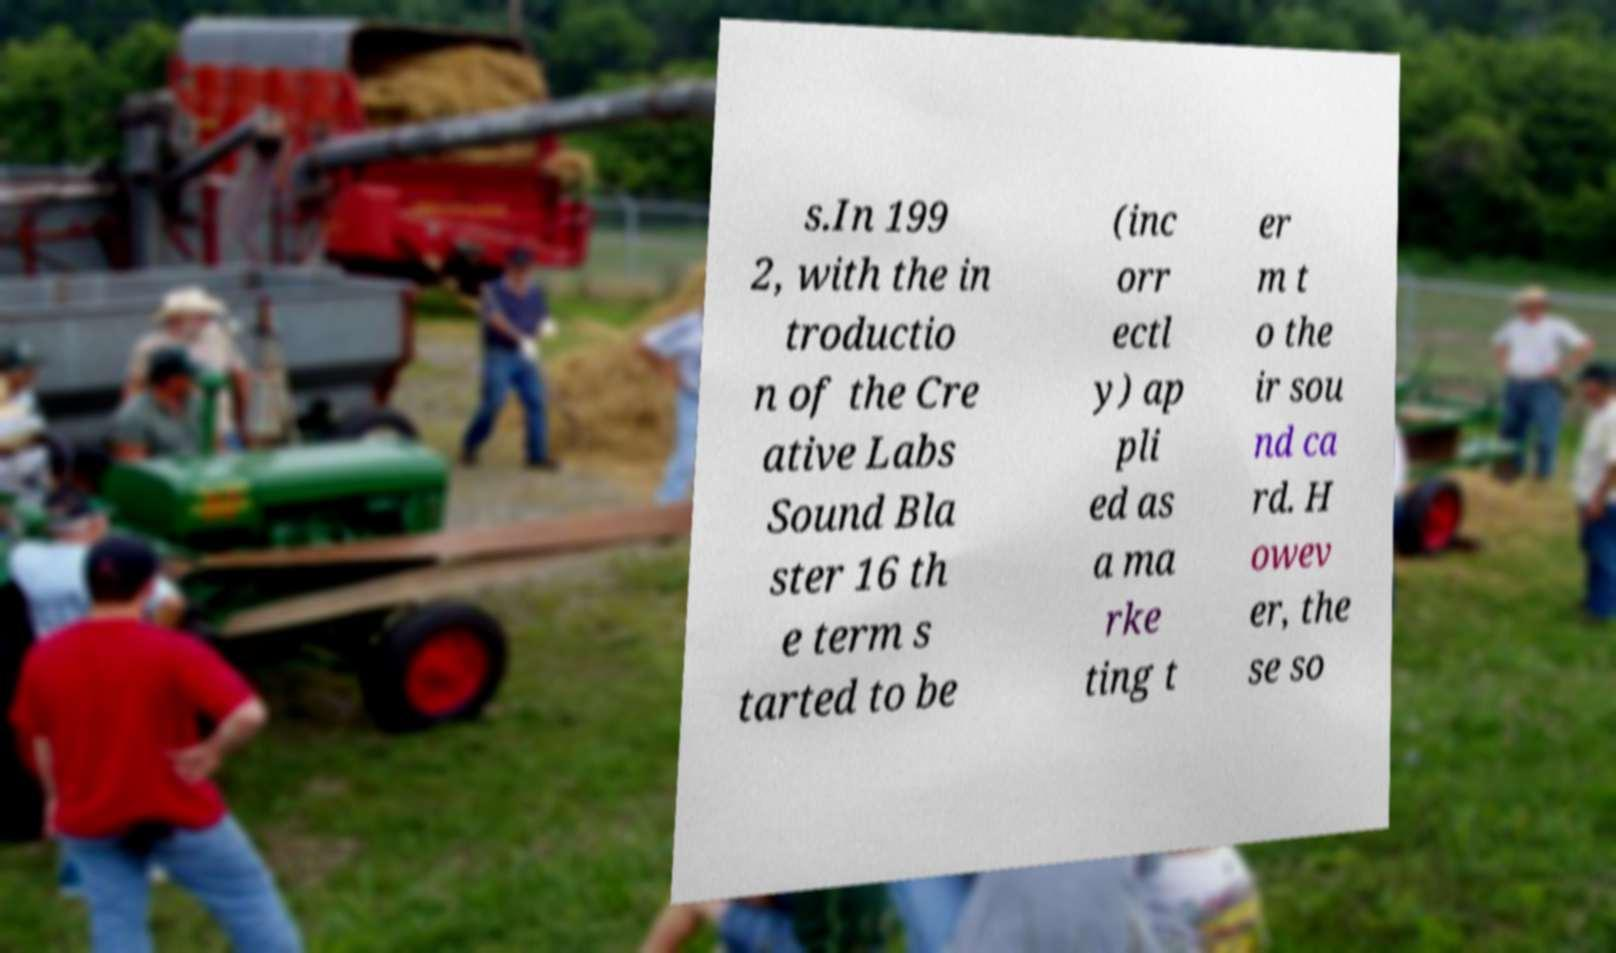Please read and relay the text visible in this image. What does it say? s.In 199 2, with the in troductio n of the Cre ative Labs Sound Bla ster 16 th e term s tarted to be (inc orr ectl y) ap pli ed as a ma rke ting t er m t o the ir sou nd ca rd. H owev er, the se so 